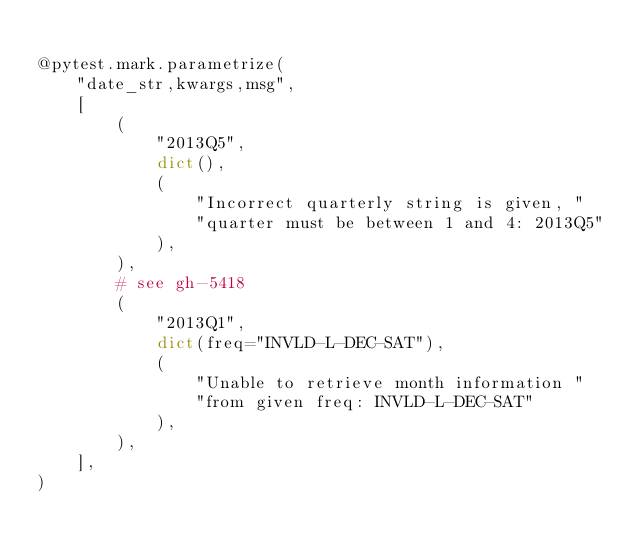Convert code to text. <code><loc_0><loc_0><loc_500><loc_500><_Python_>
@pytest.mark.parametrize(
    "date_str,kwargs,msg",
    [
        (
            "2013Q5",
            dict(),
            (
                "Incorrect quarterly string is given, "
                "quarter must be between 1 and 4: 2013Q5"
            ),
        ),
        # see gh-5418
        (
            "2013Q1",
            dict(freq="INVLD-L-DEC-SAT"),
            (
                "Unable to retrieve month information "
                "from given freq: INVLD-L-DEC-SAT"
            ),
        ),
    ],
)</code> 